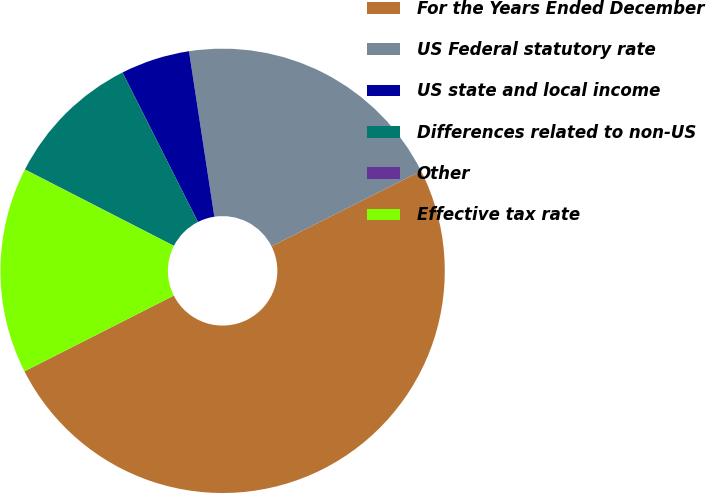Convert chart to OTSL. <chart><loc_0><loc_0><loc_500><loc_500><pie_chart><fcel>For the Years Ended December<fcel>US Federal statutory rate<fcel>US state and local income<fcel>Differences related to non-US<fcel>Other<fcel>Effective tax rate<nl><fcel>49.95%<fcel>20.0%<fcel>5.02%<fcel>10.01%<fcel>0.02%<fcel>15.0%<nl></chart> 